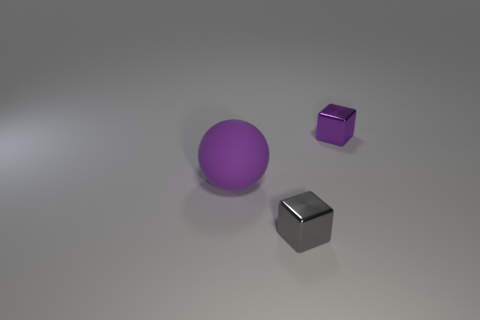Add 3 small purple metal things. How many objects exist? 6 Subtract all blocks. How many objects are left? 1 Subtract all gray metal things. Subtract all red shiny blocks. How many objects are left? 2 Add 1 blocks. How many blocks are left? 3 Add 2 yellow blocks. How many yellow blocks exist? 2 Subtract 0 yellow blocks. How many objects are left? 3 